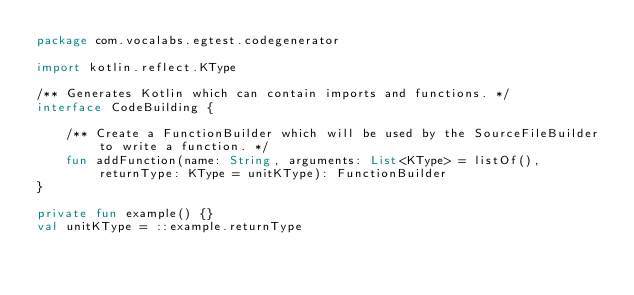<code> <loc_0><loc_0><loc_500><loc_500><_Kotlin_>package com.vocalabs.egtest.codegenerator

import kotlin.reflect.KType

/** Generates Kotlin which can contain imports and functions. */
interface CodeBuilding {

    /** Create a FunctionBuilder which will be used by the SourceFileBuilder to write a function. */
    fun addFunction(name: String, arguments: List<KType> = listOf(), returnType: KType = unitKType): FunctionBuilder
}

private fun example() {}
val unitKType = ::example.returnType
</code> 